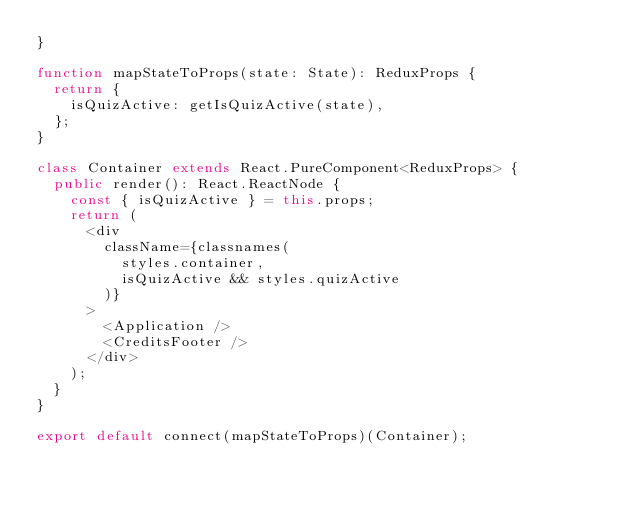<code> <loc_0><loc_0><loc_500><loc_500><_TypeScript_>}

function mapStateToProps(state: State): ReduxProps {
  return {
    isQuizActive: getIsQuizActive(state),
  };
}

class Container extends React.PureComponent<ReduxProps> {
  public render(): React.ReactNode {
    const { isQuizActive } = this.props;
    return (
      <div
        className={classnames(
          styles.container,
          isQuizActive && styles.quizActive
        )}
      >
        <Application />
        <CreditsFooter />
      </div>
    );
  }
}

export default connect(mapStateToProps)(Container);
</code> 